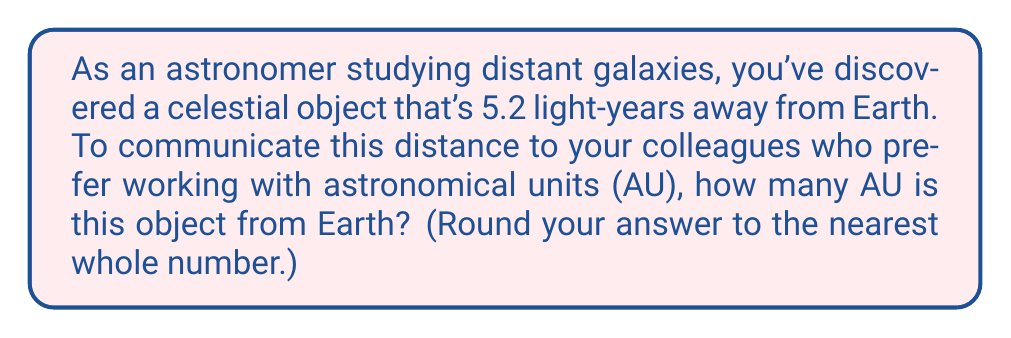Give your solution to this math problem. To solve this problem, we need to convert light-years to astronomical units. Let's break it down step-by-step:

1. Define the conversion factors:
   - 1 light-year = 9.461 × 10^12 km
   - 1 AU = 149,597,870.7 km ≈ 1.496 × 10^8 km

2. Set up the conversion:
   $$ 5.2 \text{ light-years} \times \frac{9.461 \times 10^{12} \text{ km}}{1 \text{ light-year}} \times \frac{1 \text{ AU}}{1.496 \times 10^8 \text{ km}} $$

3. Calculate:
   $$ 5.2 \times 9.461 \times 10^{12} \times \frac{1}{1.496 \times 10^8} $$
   $$ = 5.2 \times 9.461 \times \frac{10^{12}}{1.496 \times 10^8} $$
   $$ = 5.2 \times 9.461 \times 10^4 $$
   $$ = 329,153.2 \text{ AU} $$

4. Round to the nearest whole number:
   329,153 AU

Therefore, the celestial object is approximately 329,153 AU from Earth.
Answer: 329,153 AU 